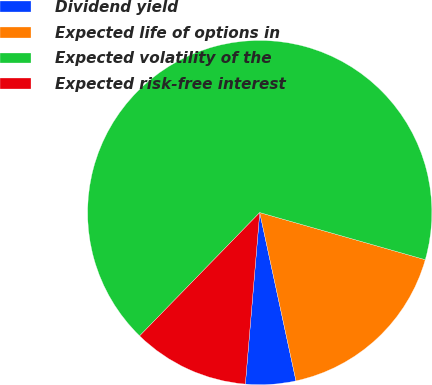<chart> <loc_0><loc_0><loc_500><loc_500><pie_chart><fcel>Dividend yield<fcel>Expected life of options in<fcel>Expected volatility of the<fcel>Expected risk-free interest<nl><fcel>4.71%<fcel>17.21%<fcel>67.13%<fcel>10.96%<nl></chart> 